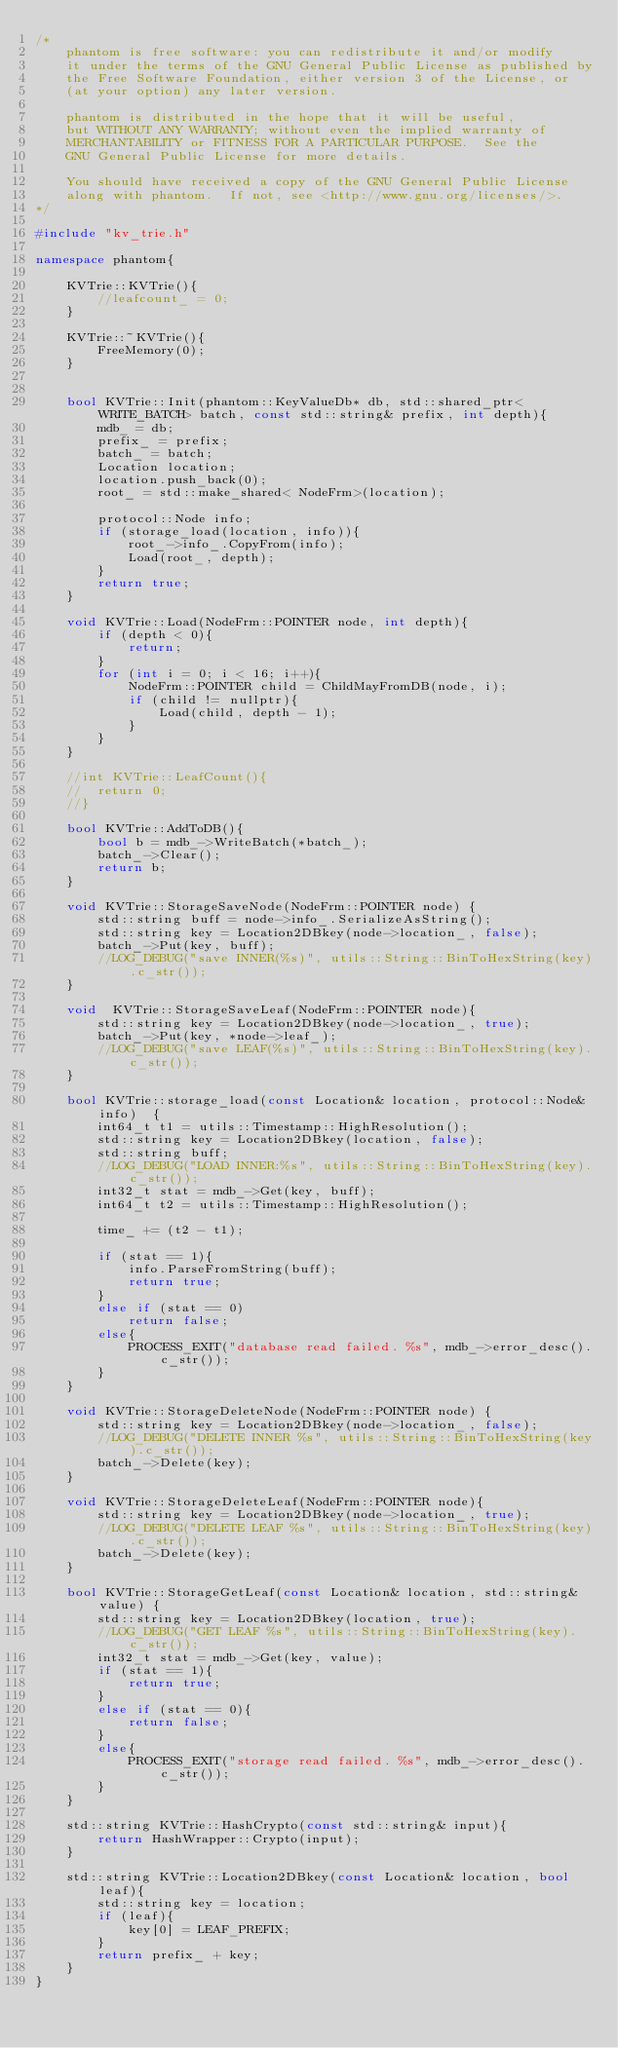<code> <loc_0><loc_0><loc_500><loc_500><_C++_>/*
	phantom is free software: you can redistribute it and/or modify
	it under the terms of the GNU General Public License as published by
	the Free Software Foundation, either version 3 of the License, or
	(at your option) any later version.

	phantom is distributed in the hope that it will be useful,
	but WITHOUT ANY WARRANTY; without even the implied warranty of
	MERCHANTABILITY or FITNESS FOR A PARTICULAR PURPOSE.  See the
	GNU General Public License for more details.

	You should have received a copy of the GNU General Public License
	along with phantom.  If not, see <http://www.gnu.org/licenses/>.
*/

#include "kv_trie.h"

namespace phantom{

	KVTrie::KVTrie(){
		//leafcount_ = 0;
	}

	KVTrie::~KVTrie(){
		FreeMemory(0);
	}


	bool KVTrie::Init(phantom::KeyValueDb* db, std::shared_ptr<WRITE_BATCH> batch, const std::string& prefix, int depth){
		mdb_ = db;
		prefix_ = prefix;
		batch_ = batch;
		Location location;
		location.push_back(0);
		root_ = std::make_shared< NodeFrm>(location);

		protocol::Node info;
		if (storage_load(location, info)){
			root_->info_.CopyFrom(info);
			Load(root_, depth);
		}
		return true;
	}

	void KVTrie::Load(NodeFrm::POINTER node, int depth){
		if (depth < 0){
			return;
		}
		for (int i = 0; i < 16; i++){
			NodeFrm::POINTER child = ChildMayFromDB(node, i);
			if (child != nullptr){
				Load(child, depth - 1);
			}
		}
	}

	//int KVTrie::LeafCount(){
	//	return 0;
	//}

	bool KVTrie::AddToDB(){
		bool b = mdb_->WriteBatch(*batch_);
		batch_->Clear();
		return b;
	}

	void KVTrie::StorageSaveNode(NodeFrm::POINTER node) {
		std::string buff = node->info_.SerializeAsString();
		std::string key = Location2DBkey(node->location_, false);
		batch_->Put(key, buff);
		//LOG_DEBUG("save INNER(%s)", utils::String::BinToHexString(key).c_str());
	}

	void  KVTrie::StorageSaveLeaf(NodeFrm::POINTER node){
		std::string key = Location2DBkey(node->location_, true);
		batch_->Put(key, *node->leaf_);
		//LOG_DEBUG("save LEAF(%s)", utils::String::BinToHexString(key).c_str());
	}

	bool KVTrie::storage_load(const Location& location, protocol::Node& info)  {
		int64_t t1 = utils::Timestamp::HighResolution();
		std::string key = Location2DBkey(location, false);
		std::string buff;
		//LOG_DEBUG("LOAD INNER:%s", utils::String::BinToHexString(key).c_str());
		int32_t stat = mdb_->Get(key, buff);
		int64_t t2 = utils::Timestamp::HighResolution();

		time_ += (t2 - t1);

		if (stat == 1){
			info.ParseFromString(buff);
			return true;
		}
		else if (stat == 0)
			return false;
		else{
			PROCESS_EXIT("database read failed. %s", mdb_->error_desc().c_str());
		}
	}

	void KVTrie::StorageDeleteNode(NodeFrm::POINTER node) {
		std::string key = Location2DBkey(node->location_, false);
		//LOG_DEBUG("DELETE INNER %s", utils::String::BinToHexString(key).c_str());
		batch_->Delete(key);
	}

	void KVTrie::StorageDeleteLeaf(NodeFrm::POINTER node){
		std::string key = Location2DBkey(node->location_, true);
		//LOG_DEBUG("DELETE LEAF %s", utils::String::BinToHexString(key).c_str());
		batch_->Delete(key);
	}

	bool KVTrie::StorageGetLeaf(const Location& location, std::string& value) {
		std::string key = Location2DBkey(location, true);
		//LOG_DEBUG("GET LEAF %s", utils::String::BinToHexString(key).c_str());
		int32_t stat = mdb_->Get(key, value);
		if (stat == 1){
			return true;
		}
		else if (stat == 0){
			return false;
		}
		else{
			PROCESS_EXIT("storage read failed. %s", mdb_->error_desc().c_str());
		}
	}

	std::string KVTrie::HashCrypto(const std::string& input){
		return HashWrapper::Crypto(input);
	}

	std::string KVTrie::Location2DBkey(const Location& location, bool leaf){
		std::string key = location;
		if (leaf){
			key[0] = LEAF_PREFIX;
		}
		return prefix_ + key;
	}
}

</code> 